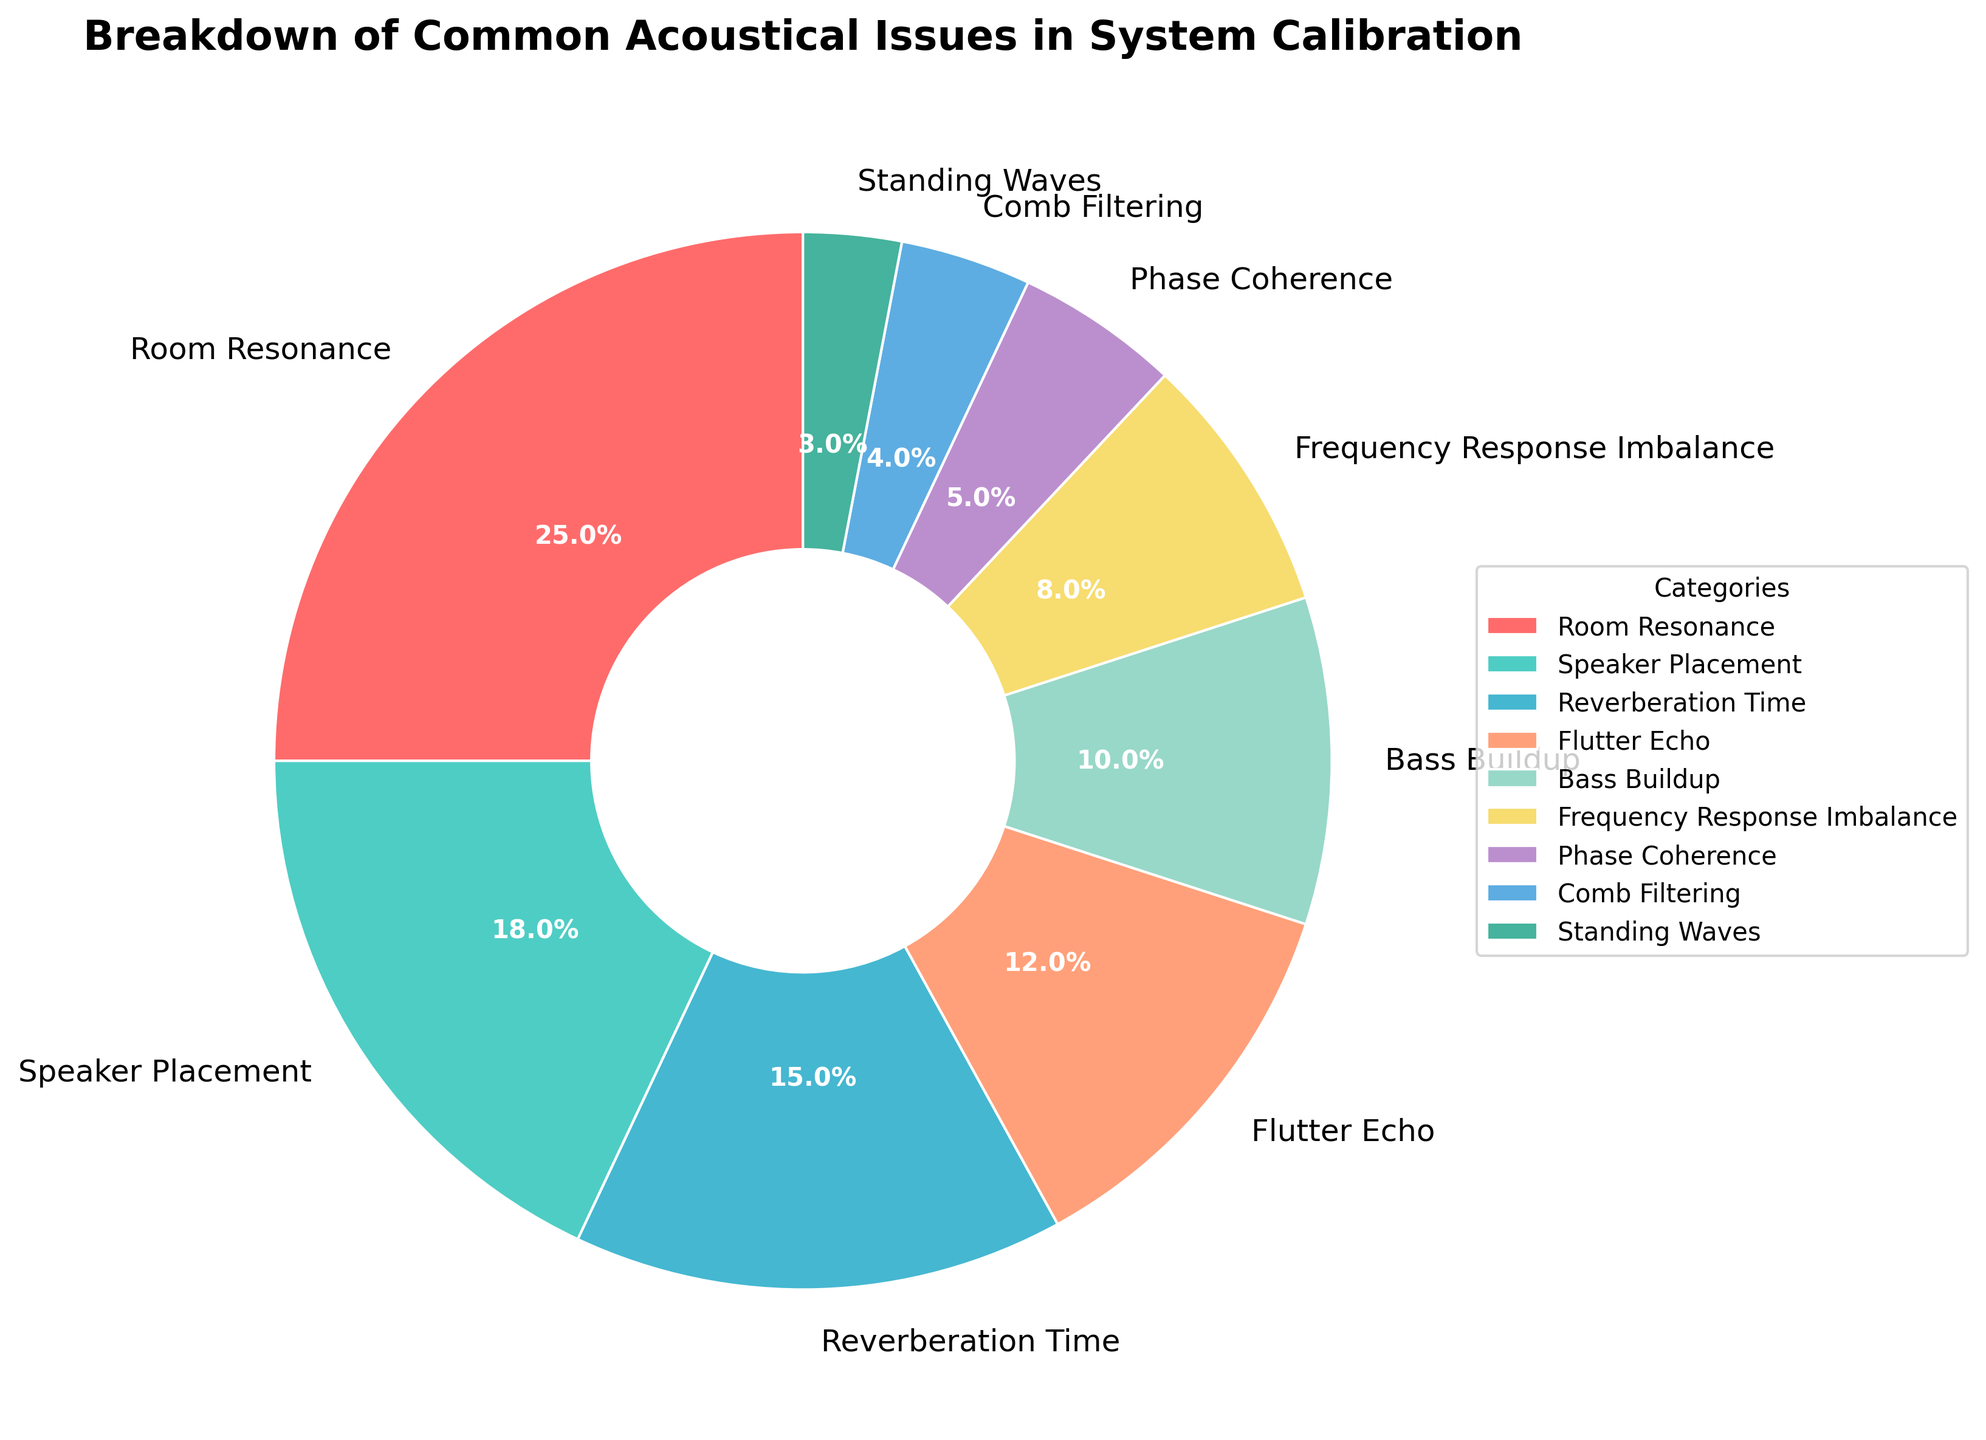What is the most common acoustical issue in system calibration according to the pie chart? The pie chart shows several categories with their respective percentages. The largest slice of the pie chart corresponds to "Room Resonance" with 25%.
Answer: Room Resonance Which acoustical issue occupies the smallest portion of the pie chart? By looking at the smallest segment in the pie chart, "Standing Waves" has the smallest percentage at 3%.
Answer: Standing Waves What is the combined percentage of Room Resonance and Speaker Placement issues? Add the percentages for Room Resonance (25%) and Speaker Placement (18%). The total is 25% + 18% = 43%.
Answer: 43% How does the percentage of Reverberation Time compare to that of Flutter Echo? Reverberation Time is 15% while Flutter Echo is 12%, so Reverberation Time is 3% higher than Flutter Echo.
Answer: Reverberation Time is higher If we group Reverberation Time, Flutter Echo, Comb Filtering, and Standing Waves, what is their combined percentage? Sum the percentages of these categories: Reverberation Time (15%) + Flutter Echo (12%) + Comb Filtering (4%) + Standing Waves (3%) = 34%.
Answer: 34% Is Bass Buildup more dominant than Phase Coherence? Bass Buildup accounts for 10% while Phase Coherence accounts for 5%, making Bass Buildup more dominant.
Answer: Yes What percentage do Frequency Response Imbalance and Comb Filtering together account for? Add the percentages: Frequency Response Imbalance (8%) + Comb Filtering (4%) = 12%.
Answer: 12% Which issues combined cover more than half of the pie chart? Adding the percentages for Room Resonance (25%) and Speaker Placement (18%) gives 43%. Including Reverberation Time (15%) brings the total to 58%, which is more than half.
Answer: Room Resonance, Speaker Placement, Reverberation Time Which acoustical issue is visually represented with the second-largest slice? After Room Resonance, the second-largest slice belongs to Speaker Placement at 18%.
Answer: Speaker Placement Compare the combined percentage of Phase Coherence and Standing Waves with that of Flutter Echo. Which is larger? The combined percentage of Phase Coherence (5%) and Standing Waves (3%) is 8%. Flutter Echo alone is 12%. Thus, Flutter Echo is larger.
Answer: Flutter Echo is larger 